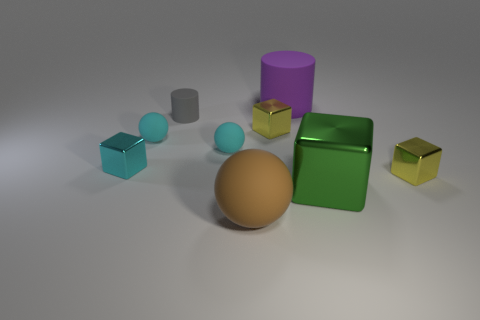If I were to arrange these objects from smallest to largest, what order would they be in? To arrange these objects from smallest to largest, you would likely start with the smaller spheres, followed by the blue cube, the metal blocks, the larger spheres, and finally, the cylinders, with the purple one being the largest object in the set. 